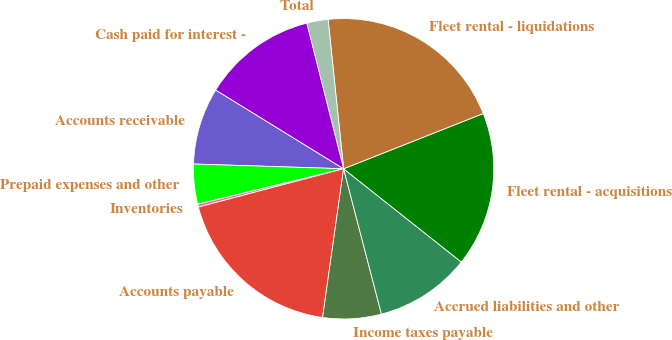Convert chart to OTSL. <chart><loc_0><loc_0><loc_500><loc_500><pie_chart><fcel>Accounts receivable<fcel>Prepaid expenses and other<fcel>Inventories<fcel>Accounts payable<fcel>Income taxes payable<fcel>Accrued liabilities and other<fcel>Fleet rental - acquisitions<fcel>Fleet rental - liquidations<fcel>Total<fcel>Cash paid for interest -<nl><fcel>8.28%<fcel>4.3%<fcel>0.31%<fcel>18.66%<fcel>6.29%<fcel>10.28%<fcel>16.66%<fcel>20.65%<fcel>2.3%<fcel>12.27%<nl></chart> 